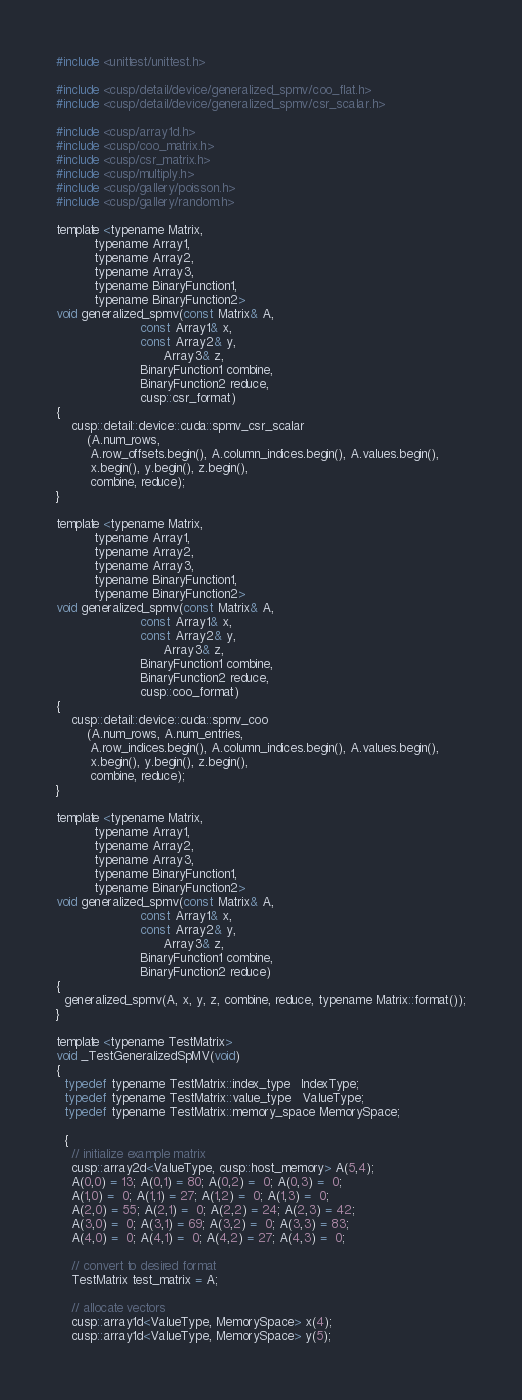Convert code to text. <code><loc_0><loc_0><loc_500><loc_500><_Cuda_>#include <unittest/unittest.h>

#include <cusp/detail/device/generalized_spmv/coo_flat.h>
#include <cusp/detail/device/generalized_spmv/csr_scalar.h>

#include <cusp/array1d.h>
#include <cusp/coo_matrix.h>
#include <cusp/csr_matrix.h>
#include <cusp/multiply.h>
#include <cusp/gallery/poisson.h>
#include <cusp/gallery/random.h>

template <typename Matrix,
          typename Array1,
          typename Array2,
          typename Array3,
          typename BinaryFunction1,
          typename BinaryFunction2>
void generalized_spmv(const Matrix& A,
                      const Array1& x,
                      const Array2& y,
                            Array3& z,
                      BinaryFunction1 combine,
                      BinaryFunction2 reduce,
                      cusp::csr_format)
{
    cusp::detail::device::cuda::spmv_csr_scalar
        (A.num_rows,
         A.row_offsets.begin(), A.column_indices.begin(), A.values.begin(),
         x.begin(), y.begin(), z.begin(),
         combine, reduce);
}

template <typename Matrix,
          typename Array1,
          typename Array2,
          typename Array3,
          typename BinaryFunction1,
          typename BinaryFunction2>
void generalized_spmv(const Matrix& A,
                      const Array1& x,
                      const Array2& y,
                            Array3& z,
                      BinaryFunction1 combine,
                      BinaryFunction2 reduce,
                      cusp::coo_format)
{
    cusp::detail::device::cuda::spmv_coo
        (A.num_rows, A.num_entries,
         A.row_indices.begin(), A.column_indices.begin(), A.values.begin(),
         x.begin(), y.begin(), z.begin(),
         combine, reduce);
}

template <typename Matrix,
          typename Array1,
          typename Array2,
          typename Array3,
          typename BinaryFunction1,
          typename BinaryFunction2>
void generalized_spmv(const Matrix& A,
                      const Array1& x,
                      const Array2& y,
                            Array3& z,
                      BinaryFunction1 combine,
                      BinaryFunction2 reduce)
{
  generalized_spmv(A, x, y, z, combine, reduce, typename Matrix::format());
}

template <typename TestMatrix>
void _TestGeneralizedSpMV(void)
{
  typedef typename TestMatrix::index_type   IndexType;
  typedef typename TestMatrix::value_type   ValueType;
  typedef typename TestMatrix::memory_space MemorySpace;

  {
    // initialize example matrix
    cusp::array2d<ValueType, cusp::host_memory> A(5,4);
    A(0,0) = 13; A(0,1) = 80; A(0,2) =  0; A(0,3) =  0; 
    A(1,0) =  0; A(1,1) = 27; A(1,2) =  0; A(1,3) =  0;
    A(2,0) = 55; A(2,1) =  0; A(2,2) = 24; A(2,3) = 42;
    A(3,0) =  0; A(3,1) = 69; A(3,2) =  0; A(3,3) = 83;
    A(4,0) =  0; A(4,1) =  0; A(4,2) = 27; A(4,3) =  0;

    // convert to desired format
    TestMatrix test_matrix = A;

    // allocate vectors
    cusp::array1d<ValueType, MemorySpace> x(4);
    cusp::array1d<ValueType, MemorySpace> y(5);</code> 